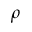Convert formula to latex. <formula><loc_0><loc_0><loc_500><loc_500>\rho</formula> 